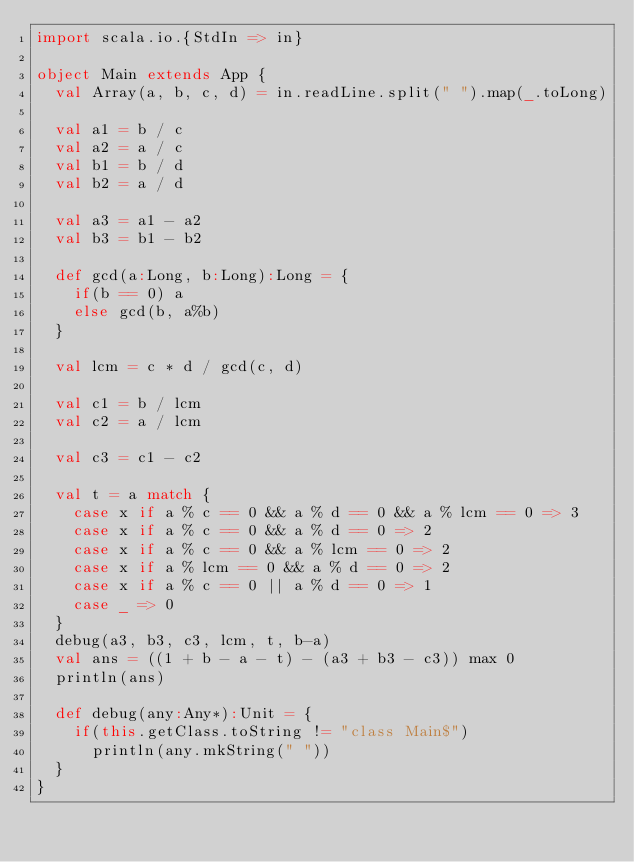<code> <loc_0><loc_0><loc_500><loc_500><_Scala_>import scala.io.{StdIn => in}

object Main extends App {
  val Array(a, b, c, d) = in.readLine.split(" ").map(_.toLong)

  val a1 = b / c
  val a2 = a / c
  val b1 = b / d
  val b2 = a / d

  val a3 = a1 - a2
  val b3 = b1 - b2

  def gcd(a:Long, b:Long):Long = {
    if(b == 0) a
    else gcd(b, a%b)
  }

  val lcm = c * d / gcd(c, d)

  val c1 = b / lcm
  val c2 = a / lcm

  val c3 = c1 - c2

  val t = a match {
    case x if a % c == 0 && a % d == 0 && a % lcm == 0 => 3
    case x if a % c == 0 && a % d == 0 => 2
    case x if a % c == 0 && a % lcm == 0 => 2
    case x if a % lcm == 0 && a % d == 0 => 2
    case x if a % c == 0 || a % d == 0 => 1
    case _ => 0
  }
  debug(a3, b3, c3, lcm, t, b-a)
  val ans = ((1 + b - a - t) - (a3 + b3 - c3)) max 0
  println(ans)

  def debug(any:Any*):Unit = {
    if(this.getClass.toString != "class Main$")
      println(any.mkString(" "))
  }
}</code> 